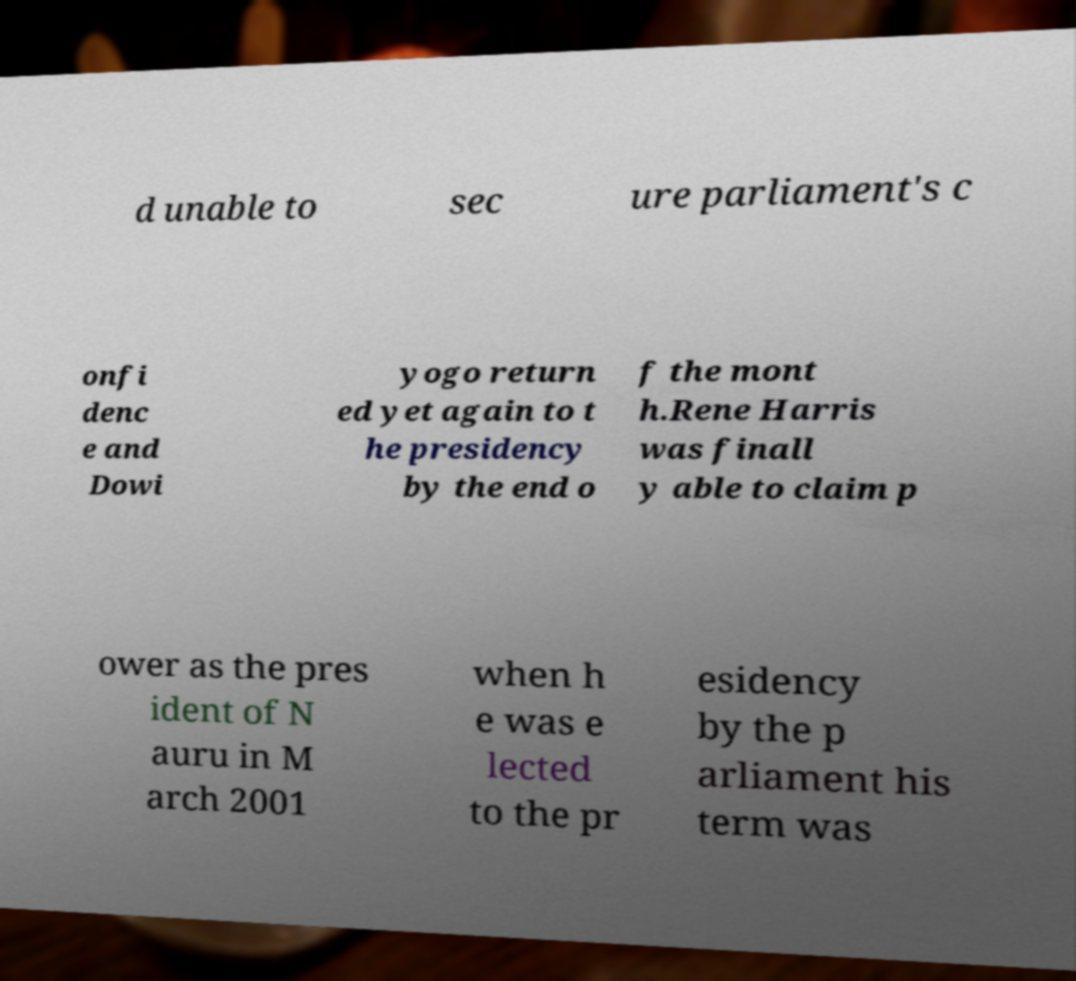Can you accurately transcribe the text from the provided image for me? d unable to sec ure parliament's c onfi denc e and Dowi yogo return ed yet again to t he presidency by the end o f the mont h.Rene Harris was finall y able to claim p ower as the pres ident of N auru in M arch 2001 when h e was e lected to the pr esidency by the p arliament his term was 